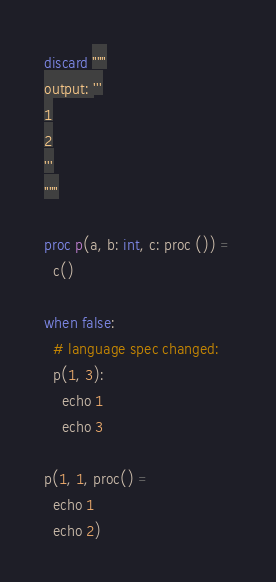<code> <loc_0><loc_0><loc_500><loc_500><_Nim_>discard """
output: '''
1
2
'''
"""

proc p(a, b: int, c: proc ()) =
  c()

when false:
  # language spec changed:
  p(1, 3):
    echo 1
    echo 3

p(1, 1, proc() =
  echo 1
  echo 2)
</code> 